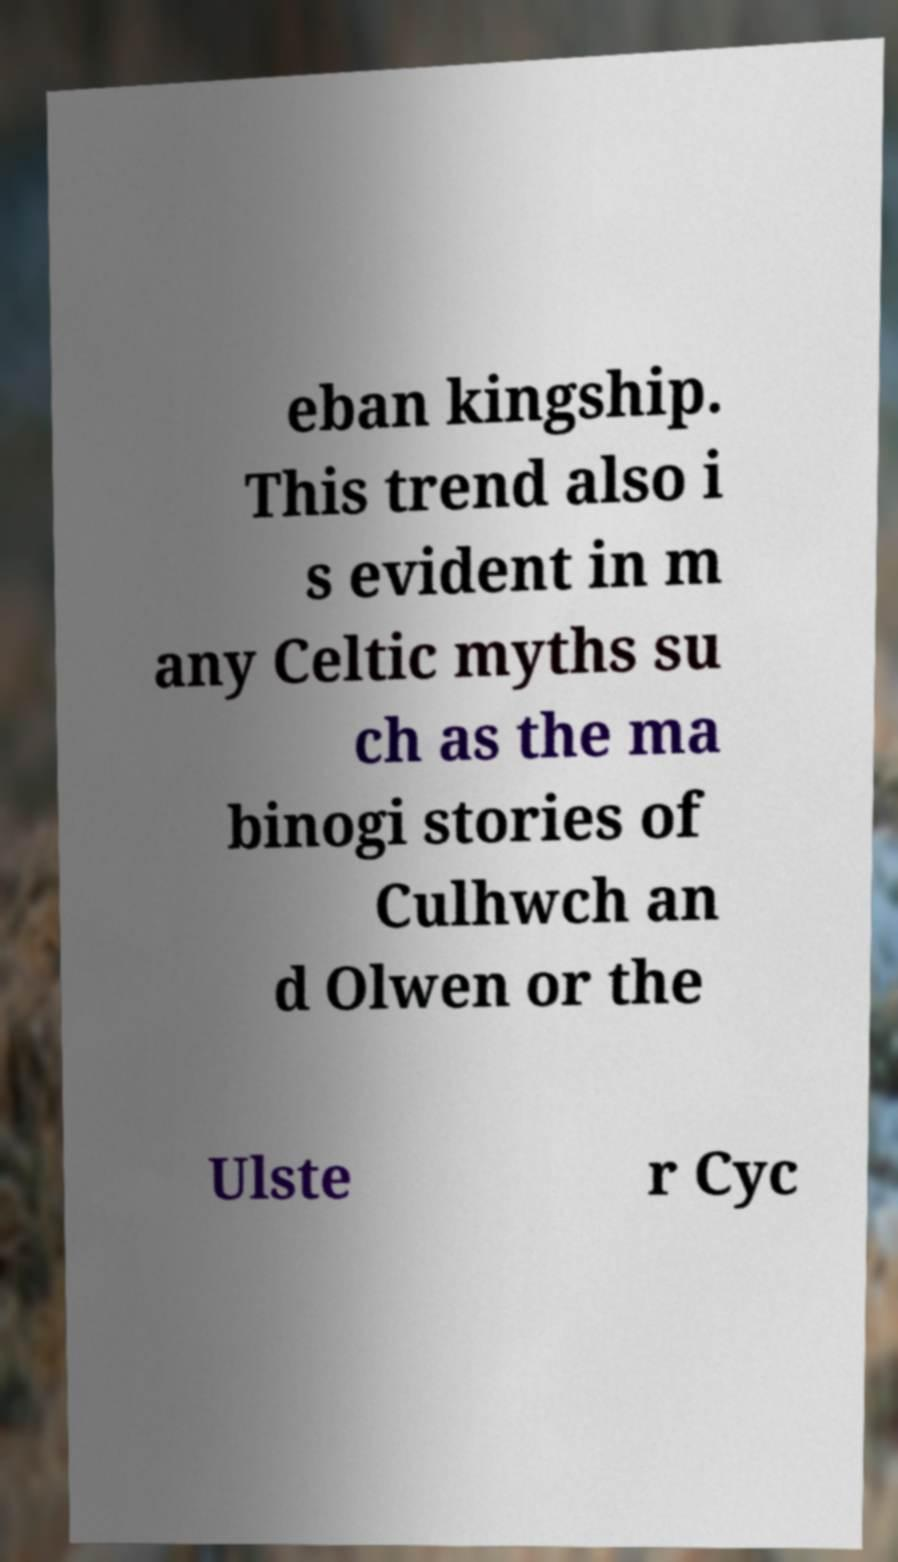I need the written content from this picture converted into text. Can you do that? eban kingship. This trend also i s evident in m any Celtic myths su ch as the ma binogi stories of Culhwch an d Olwen or the Ulste r Cyc 